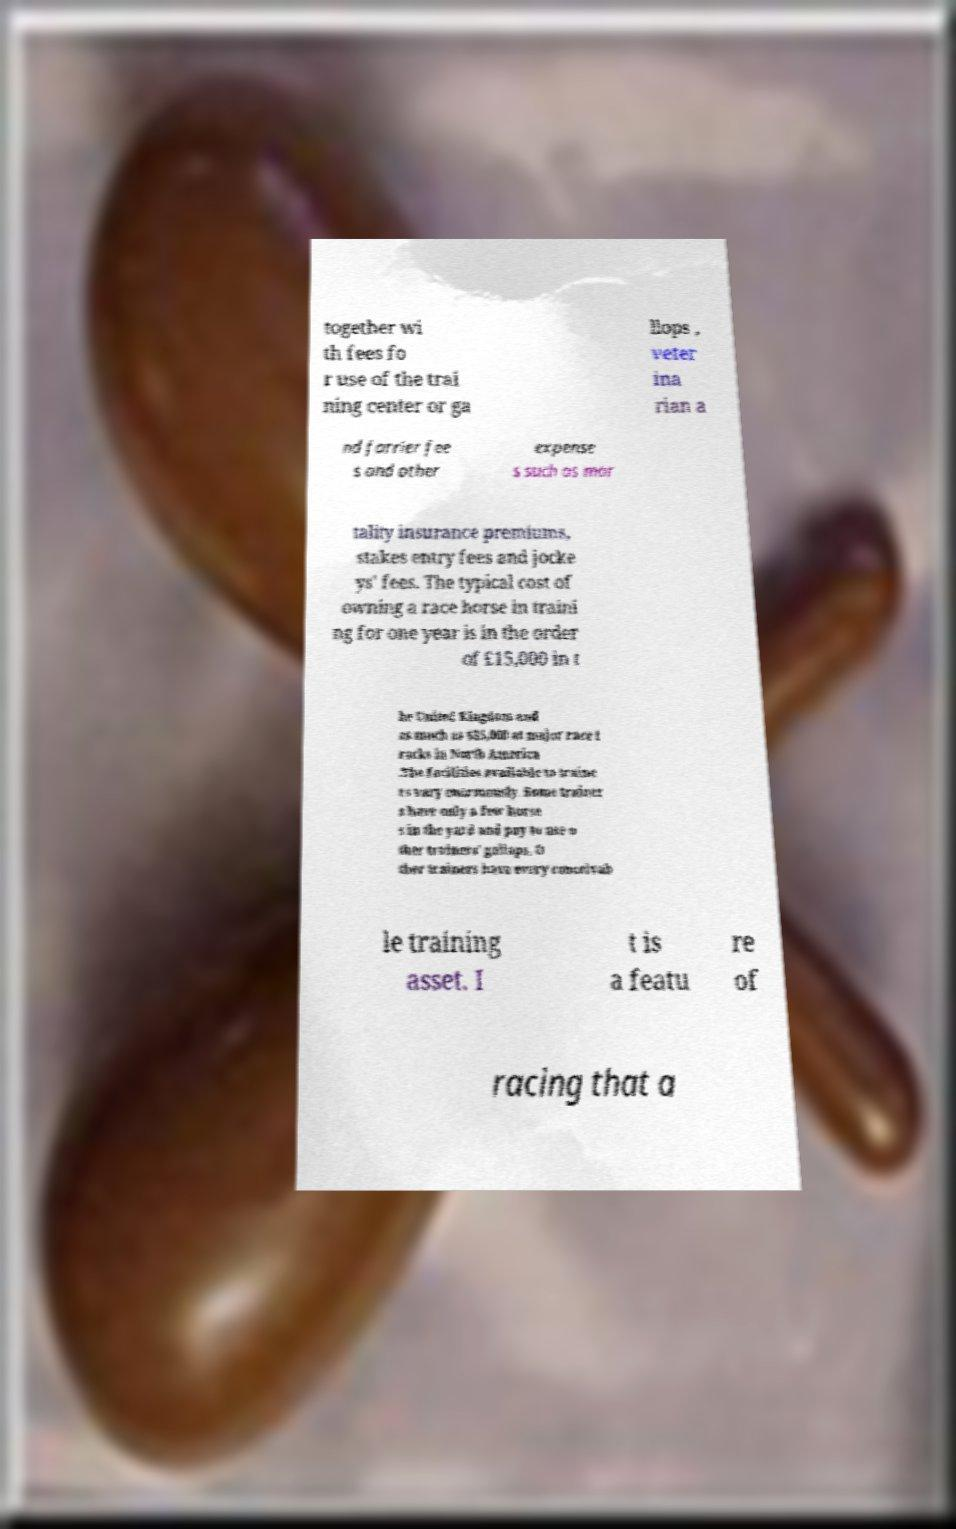There's text embedded in this image that I need extracted. Can you transcribe it verbatim? together wi th fees fo r use of the trai ning center or ga llops , veter ina rian a nd farrier fee s and other expense s such as mor tality insurance premiums, stakes entry fees and jocke ys' fees. The typical cost of owning a race horse in traini ng for one year is in the order of £15,000 in t he United Kingdom and as much as $35,000 at major race t racks in North America .The facilities available to traine rs vary enormously. Some trainer s have only a few horse s in the yard and pay to use o ther trainers' gallops. O ther trainers have every conceivab le training asset. I t is a featu re of racing that a 